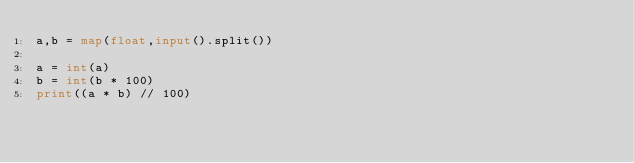<code> <loc_0><loc_0><loc_500><loc_500><_Python_>a,b = map(float,input().split())

a = int(a)
b = int(b * 100)
print((a * b) // 100)</code> 